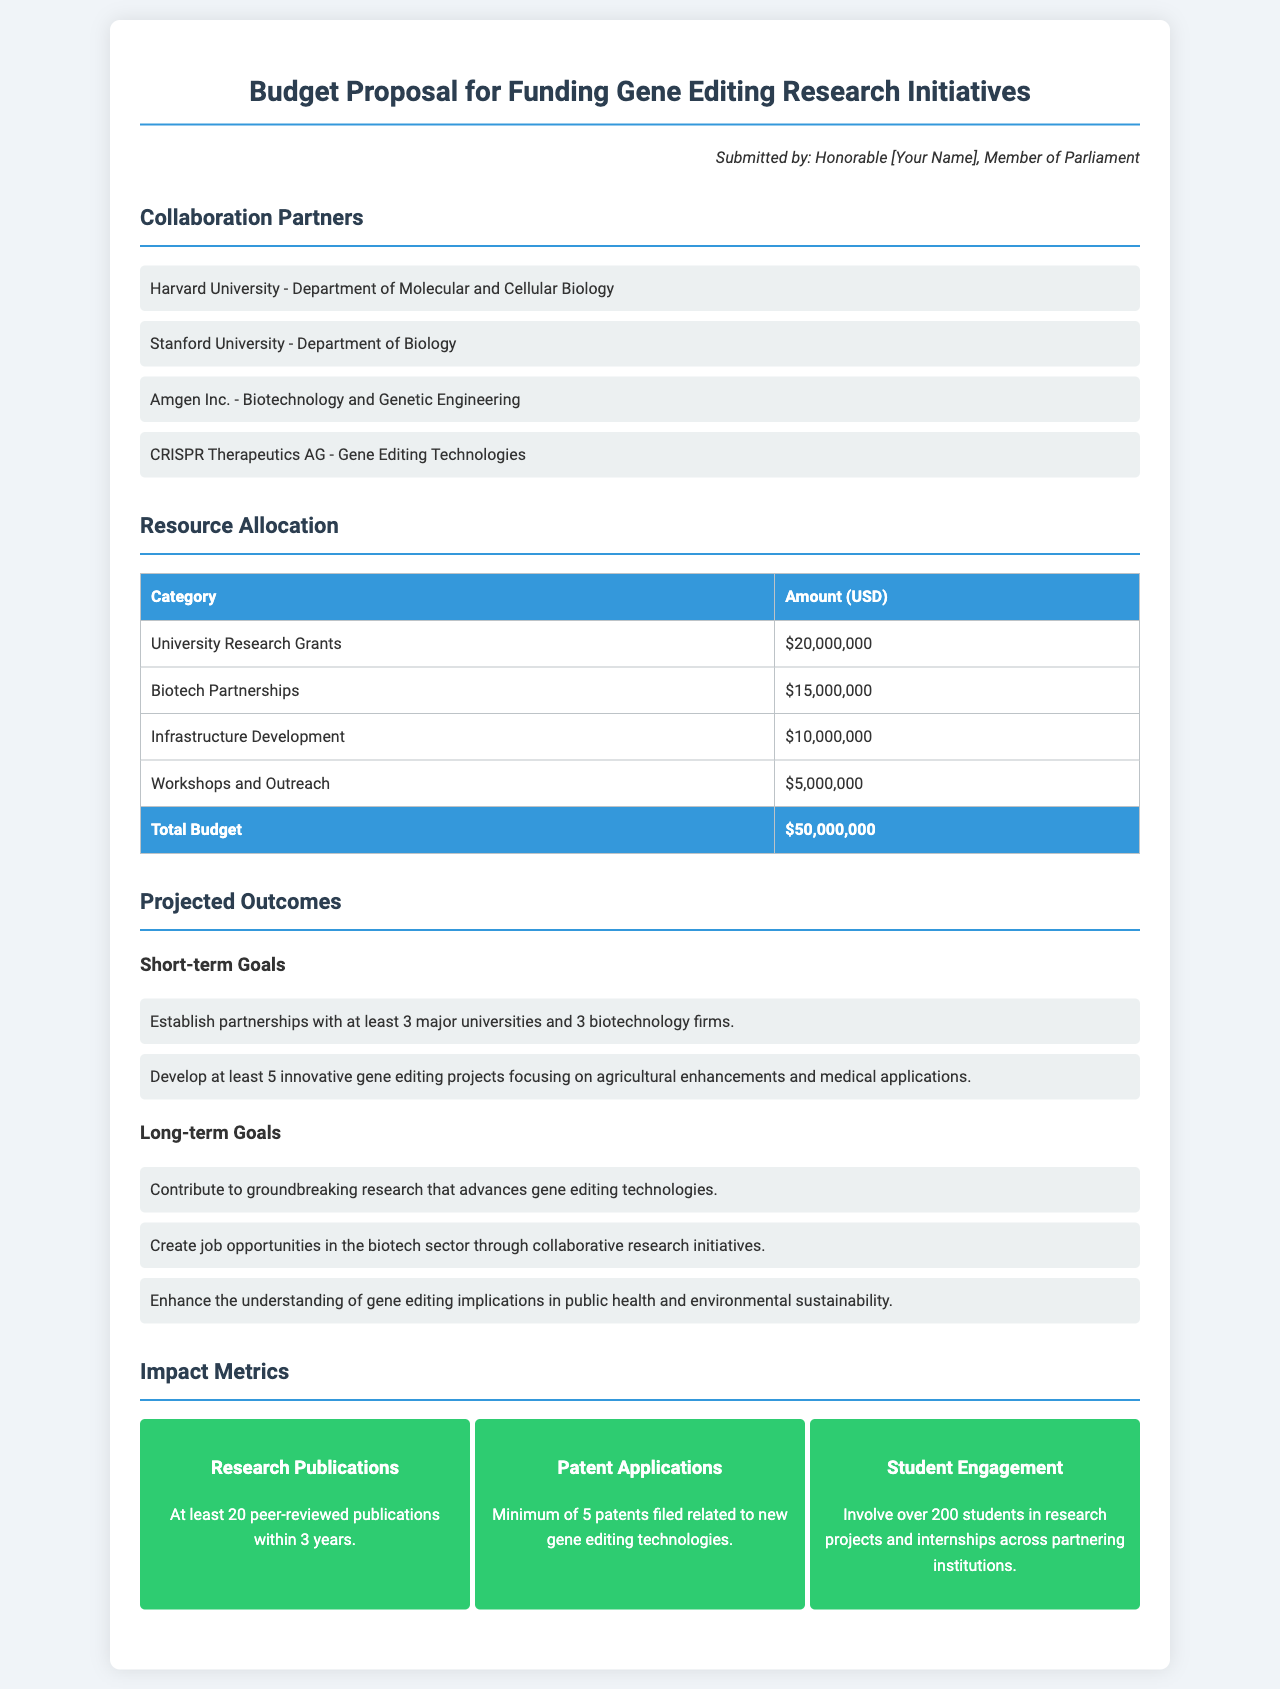What is the total budget? The total budget is listed in the resource allocation section as the sum of all categories, amounting to $50,000,000.
Answer: $50,000,000 Which university's department is mentioned first as a collaboration partner? The first university mentioned in the collaboration partners section is Harvard University - Department of Molecular and Cellular Biology.
Answer: Harvard University - Department of Molecular and Cellular Biology How much funding is allocated for University Research Grants? The amount allocated for University Research Grants is specified in the resource allocation table as $20,000,000.
Answer: $20,000,000 What is one of the short-term goals for the gene editing initiatives? One of the short-term goals mentioned is to establish partnerships with at least 3 major universities and 3 biotechnology firms.
Answer: Establish partnerships with at least 3 major universities and 3 biotechnology firms How many patents are expected to be filed related to new gene editing technologies? The document states that a minimum of 5 patents are anticipated to be filed.
Answer: 5 patents What type of opportunities will the long-term goals aim to create? The long-term goals aim to create job opportunities in the biotech sector.
Answer: Job opportunities in the biotech sector What is the expected number of peer-reviewed publications within 3 years? The expected number of peer-reviewed publications is indicated as at least 20 publications within 3 years.
Answer: 20 publications How much funding is allocated for Workshops and Outreach? The funding allocated for Workshops and Outreach is listed as $5,000,000 in the resource allocation section.
Answer: $5,000,000 